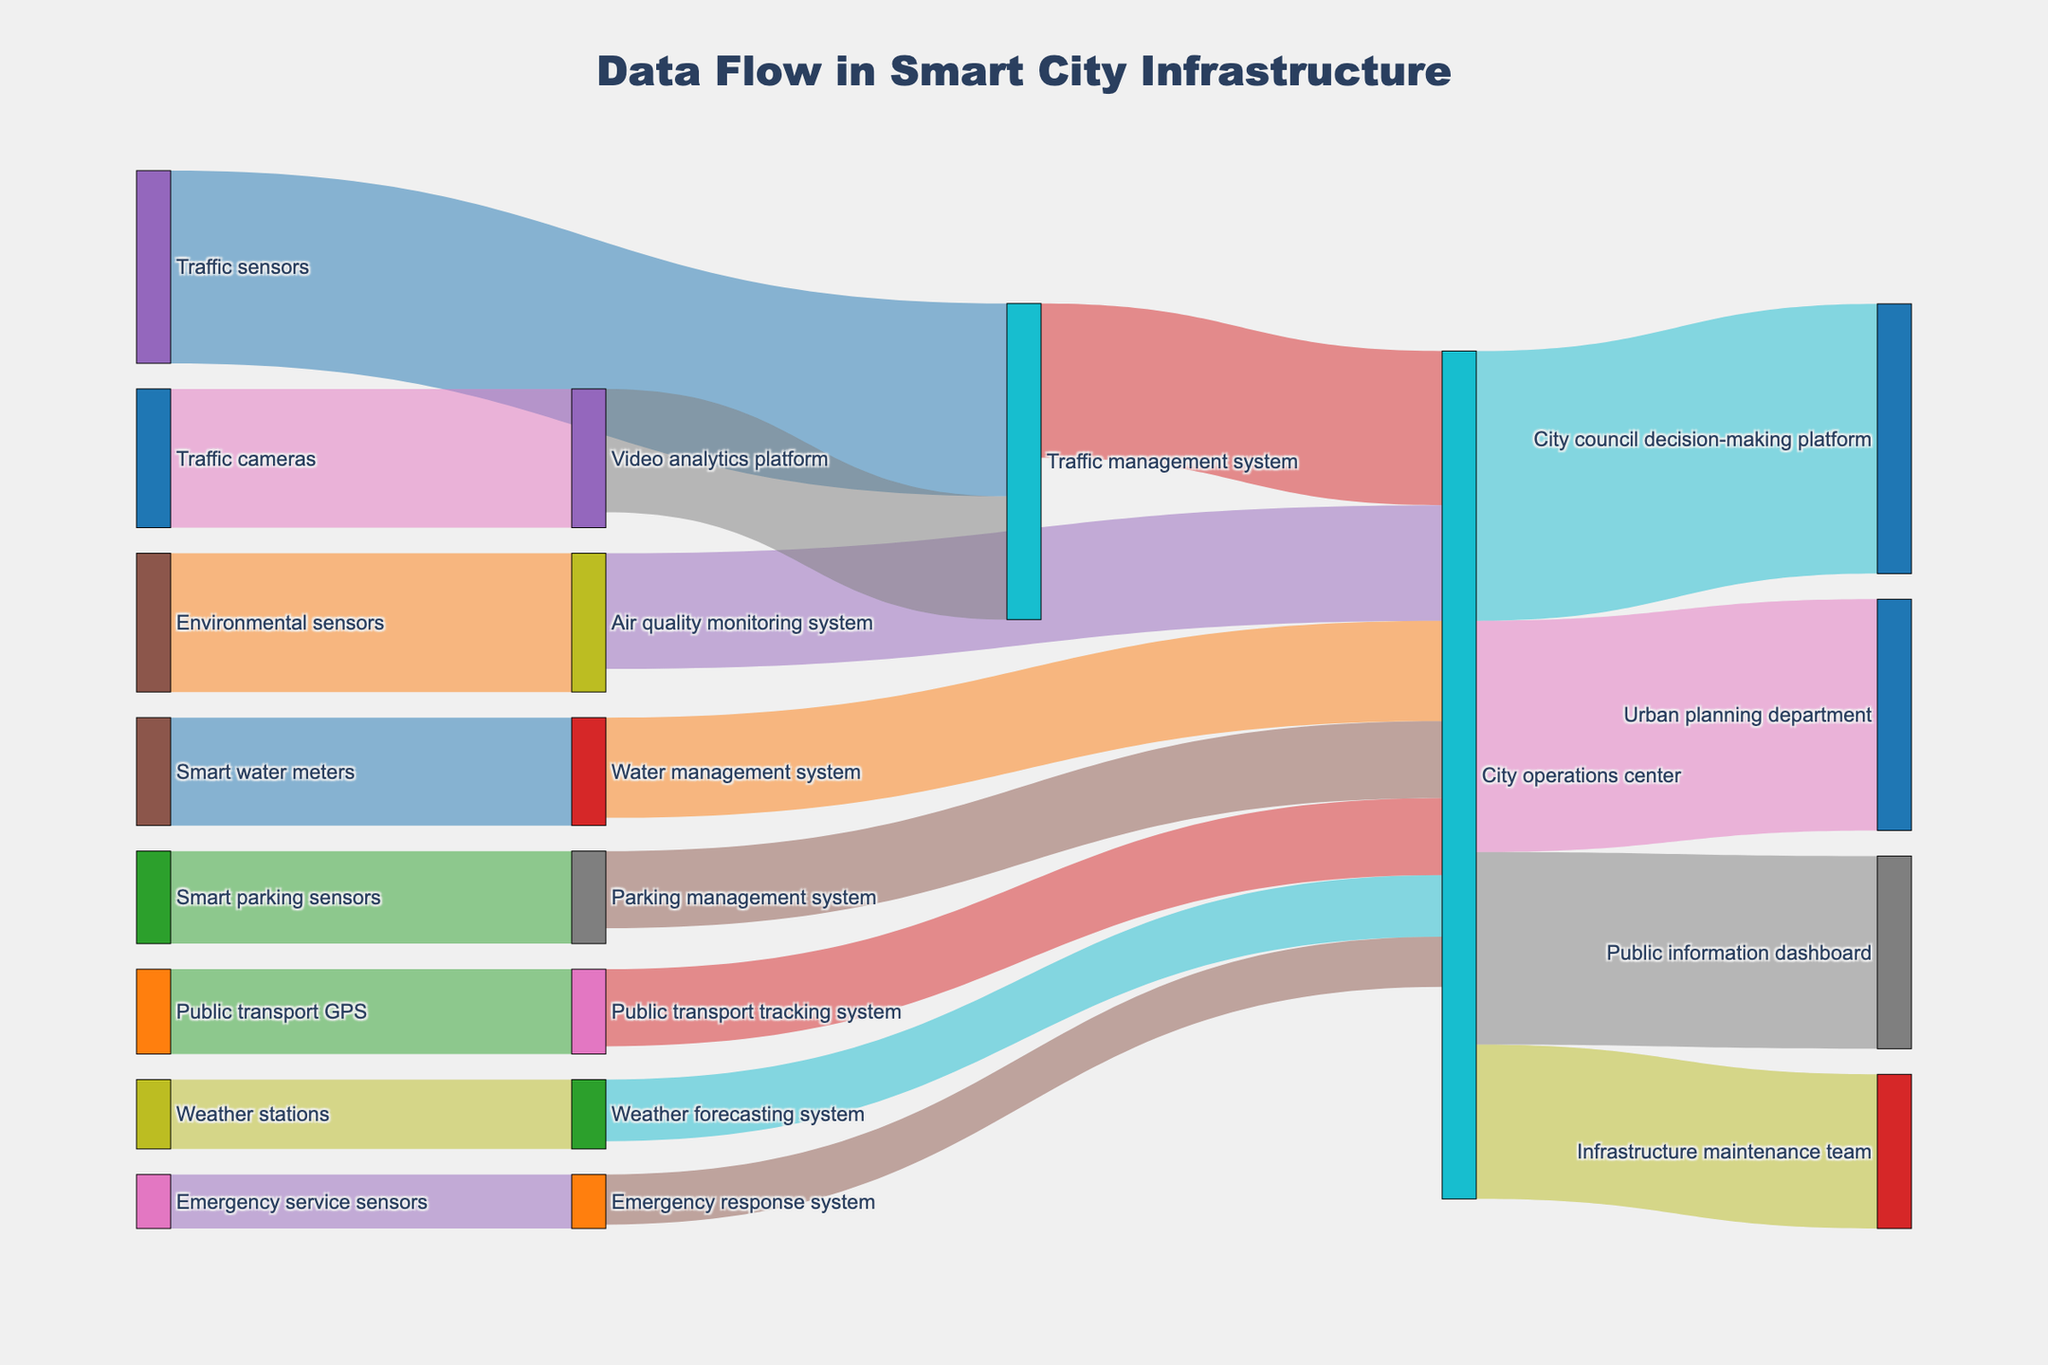What is the title of the diagram? The title is typically found at the top center of the diagram. In this Sankey diagram, the title is written clearly as "Data Flow in Smart City Infrastructure."
Answer: Data Flow in Smart City Infrastructure How many source nodes are there in the diagram? Source nodes are the origin points from which data flows. By counting the distinct nodes listed as sources in the dataset, we find there are 8 source nodes: Traffic sensors, Environmental sensors, Smart parking sensors, Traffic cameras, Weather stations, Smart water meters, Public transport GPS, and Emergency service sensors.
Answer: 8 What is the entity that receives the highest data flow from the City operations center? The City operations center sends data to multiple entities. By comparing the values, we see that the City council decision-making platform receives 350, which is the maximum.
Answer: City council decision-making platform Which sensor type contributes the least amount of data directly to the City operations center? To find this, look for the sensors that send data directly to the City operations center node. Emergency response system sends the least amount (65).
Answer: Emergency response system What is the combined data flow value from Traffic management system, Air quality monitoring system, and Weather forecasting system to the City operations center? The data flow values are: Traffic management system (200), Air quality monitoring system (150), and Weather forecasting system (80). Summing them up gives 200 + 150 + 80 = 430.
Answer: 430 Which system receives data from both Traffic sensors and Video analytics platform? By following the paths from both Traffic sensors and Video analytics platform, we see that the Traffic management system receives data from both sources.
Answer: Traffic management system Is the value of data flowing from Smart parking sensors to Parking management system greater than the data flowing from Smart water meters to Water management system? Compare the values: Smart parking sensors to Parking management system (120) versus Smart water meters to Water management system (140). 120 < 140, so it is not greater.
Answer: No How does the data flow from Weather stations ultimately reach the Urban planning department? Begin at Weather stations, which flows to Weather forecasting system (90), then to City operations center (80), and finally to Urban planning department (a part of the city's output, 300). The path is "Weather stations → Weather forecasting system → City operations center → Urban planning department".
Answer: Weather stations → Weather forecasting system → City operations center → Urban planning department Which department has the highest outflow of data from the City operations center? Among the various paths originating from the City operations center, the City council decision-making platform receives the highest value of 350.
Answer: City council decision-making platform 